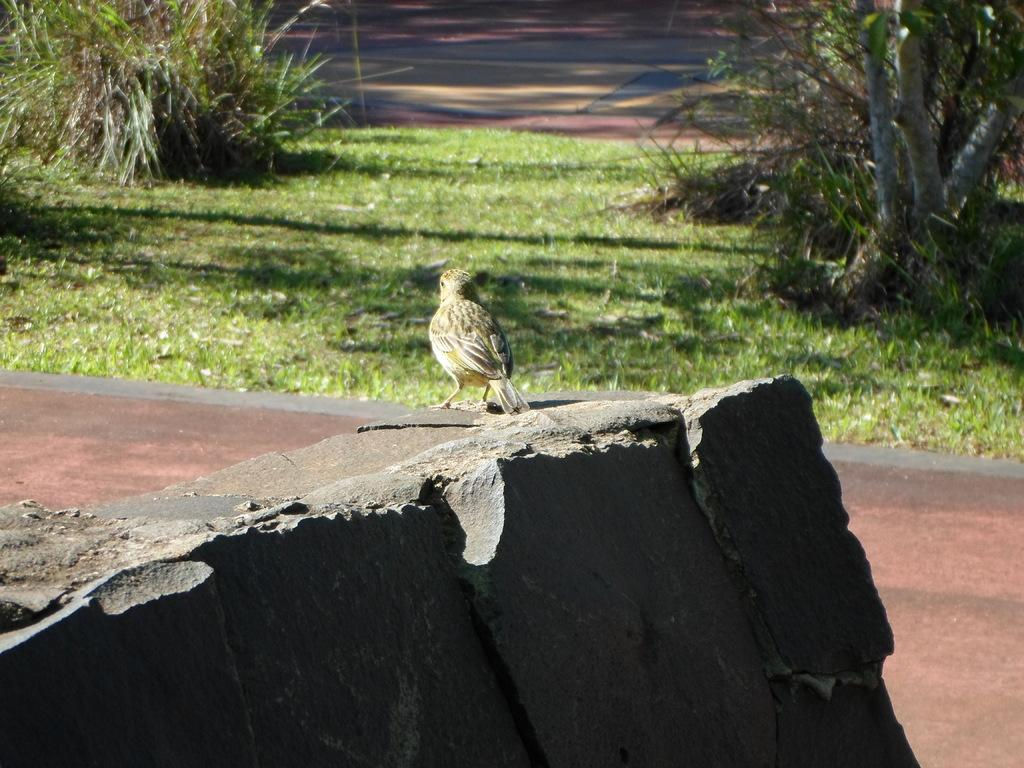What is the main subject in the center of the image? There is a stone in the center of the image. Is there any living creature on the stone? Yes, there is a bird on the stone. What can be seen in the background of the image? There are plants, grass, a road, and a few other objects in the background of the image. What type of mouth can be seen on the stone in the image? There is no mouth present on the stone in the image. What selection of planes is visible in the image? There are no planes visible in the image. 